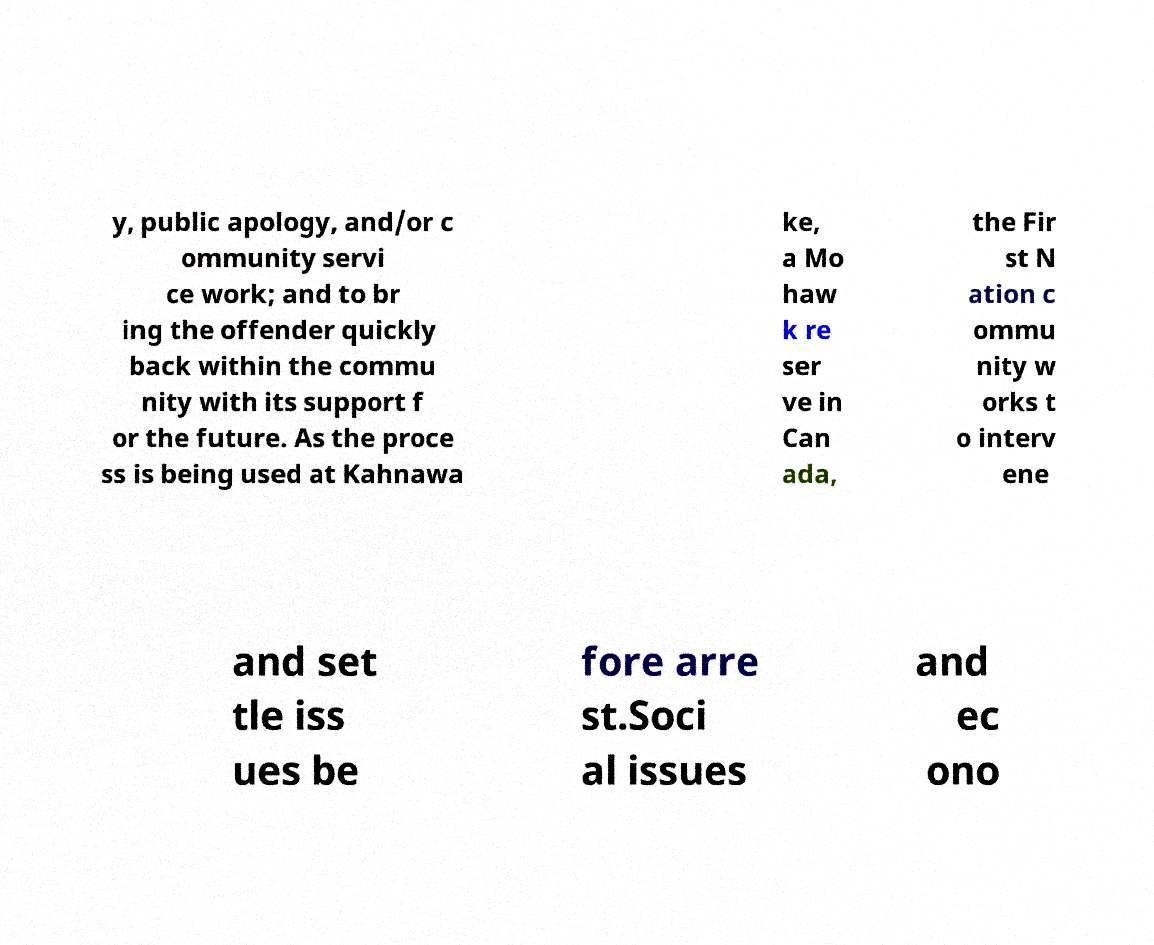What messages or text are displayed in this image? I need them in a readable, typed format. y, public apology, and/or c ommunity servi ce work; and to br ing the offender quickly back within the commu nity with its support f or the future. As the proce ss is being used at Kahnawa ke, a Mo haw k re ser ve in Can ada, the Fir st N ation c ommu nity w orks t o interv ene and set tle iss ues be fore arre st.Soci al issues and ec ono 